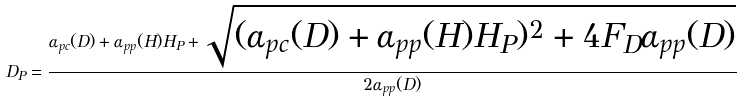Convert formula to latex. <formula><loc_0><loc_0><loc_500><loc_500>D _ { P } = \frac { \alpha _ { p c } ( D ) + \alpha _ { p p } ( H ) H _ { P } + \sqrt { ( \alpha _ { p c } ( D ) + \alpha _ { p p } ( H ) H _ { P } ) ^ { 2 } + 4 F _ { D } \alpha _ { p p } ( D ) } } { 2 \alpha _ { p p } ( D ) }</formula> 